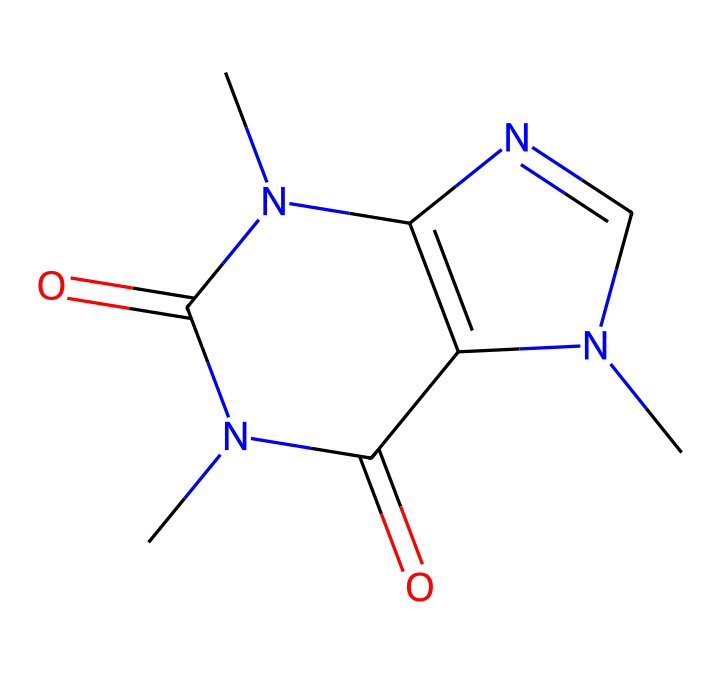What is the molecular formula of caffeine based on its structure? By analyzing the SMILES representation, we can count the number of carbon (C), hydrogen (H), nitrogen (N), and oxygen (O) atoms present. The structure consists of 8 carbon atoms, 10 hydrogen atoms, 4 nitrogen atoms, and 2 oxygen atoms, leading to the molecular formula C8H10N4O2.
Answer: C8H10N4O2 How many rings are present in the caffeine structure? We can look at the chemical structure to identify the number of cyclic (ring) components. In caffeine, there are two interconnected rings visible in its structure.
Answer: 2 What element is predominantly responsible for the bitter taste in caffeine? Caffeine contains nitrogen atoms, which are characteristic of alkaloids. Alkaloids are known to impart bitterness to substances. Hence, the nitrogen atoms in this structure indicate its bitter taste.
Answer: nitrogen How many double bonds are found in the caffeine structure? By examining the chemical structure, we can visually identify the present double bonds. In caffeine, there are two double bonds located in the ring structure, highlighting its unsaturation.
Answer: 2 What type of chemical is caffeine classified as? Caffeine is primarily classified as an alkaloid due to its nitrogen-containing structure and its physiological effects. This classification is based on its chemical features and biological properties.
Answer: alkaloid How many nitrogen atoms are present in the structure of caffeine? By inspecting the SMILES representation, we count the nitrogen (N) atoms. There are four nitrogen atoms depicted in the structure.
Answer: 4 What form of bonding is mainly present in caffeine's molecular structure? The chemical structure of caffeine primarily consists of covalent bonding, which is evidenced by the sharing of electrons between the carbon, nitrogen, and oxygen atoms within the rings.
Answer: covalent 